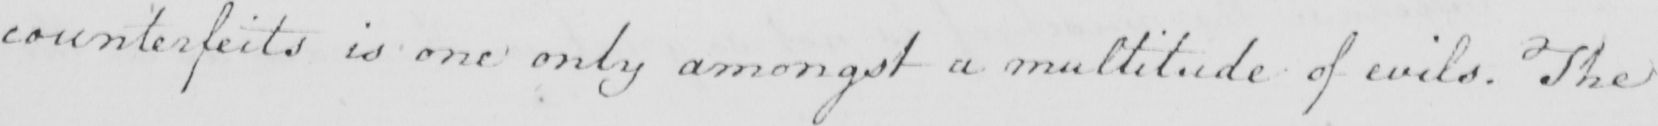Can you tell me what this handwritten text says? counterfeits is one only amongst a multitude of evils . The 